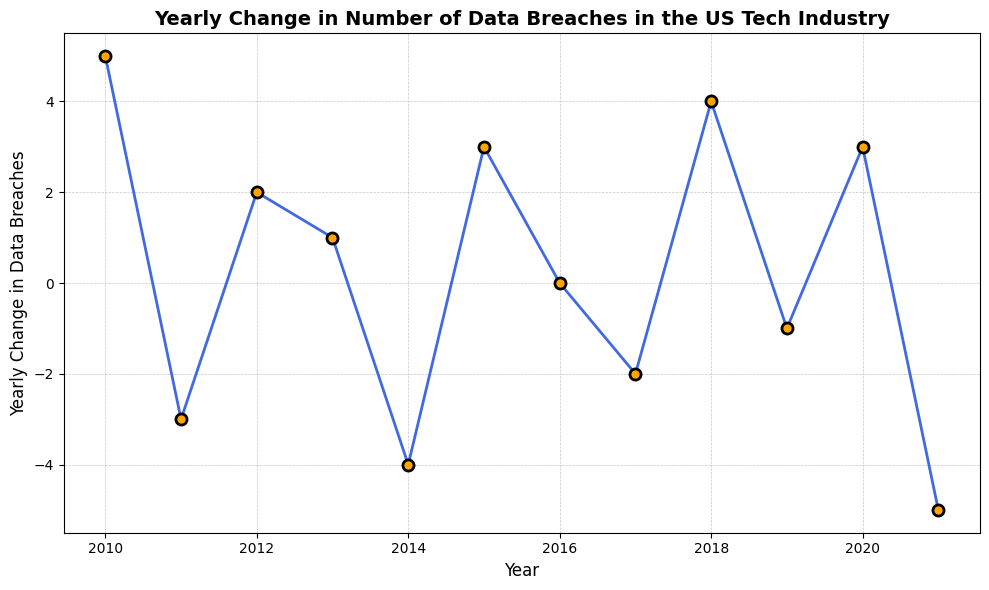What is the highest yearly change in data breaches recorded? By examining the figure, the highest data point on the y-axis corresponds to the year with the largest increase. In this case, it is 5 in 2010.
Answer: 5 Which year has the most significant negative change in data breaches? Look at the lowest point on the plot, which represents the largest negative value. This is -5 in 2021.
Answer: 2021 How many years showed a negative yearly change in data breaches? Count all the points on the plot that are below the zero line. These points are in 2011, 2014, 2017, 2019, and 2021. There are 5 such years.
Answer: 5 What is the difference in yearly change between 2010 and 2014? The yearly change in 2010 is 5 and in 2014 it is -4. Calculating the difference: 5 - (-4) = 5 + 4 = 9.
Answer: 9 What is the average yearly change in data breaches from 2019 to 2021? Extract the values between these years (2019, 2020, and 2021). They are -1, 3, and -5. Sum them up: -1 + 3 - 5 = -3. The average is -3/3 = -1.
Answer: -1 How many years showed an increase in data breaches compared to the previous year? Identify points where the change is positive: 2010, 2012, 2013, 2015, 2018, and 2020. There are 6 such years.
Answer: 6 Which years showed no change in the number of data breaches? Look at the points that are exactly on the zero line. Only 2016 fits this criterion.
Answer: 2016 In which consecutive years did the number of data breaches decrease, followed by an increase? Identify where a negative change is followed by a positive change in the next year. This happens from 2011 to 2012 (from -3 to 2), from 2014 to 2015 (from -4 to 3), and from 2017 to 2018 (from -2 to 4).
Answer: 2011-2012, 2014-2015, 2017-2018 What is the combined change in number of data breaches from 2011 to 2013? Add the changes from each year: 2011 (-3), 2012 (2), and 2013 (1). Sum: -3 + 2 + 1 = 0.
Answer: 0 Between which years did the most significant positive change occur? Calculate the difference between year-to-year changes and identify the highest positive difference. From 2014 to 2015, the change is from -4 to 3, which is 7.
Answer: 2014-2015 